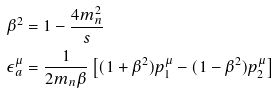<formula> <loc_0><loc_0><loc_500><loc_500>\beta ^ { 2 } & = 1 - \frac { 4 m _ { n } ^ { 2 } } { s } \\ \epsilon _ { a } ^ { \mu } & = \frac { 1 } { 2 m _ { n } \beta } \left [ ( 1 + \beta ^ { 2 } ) p _ { 1 } ^ { \mu } - ( 1 - \beta ^ { 2 } ) p _ { 2 } ^ { \mu } \right ]</formula> 